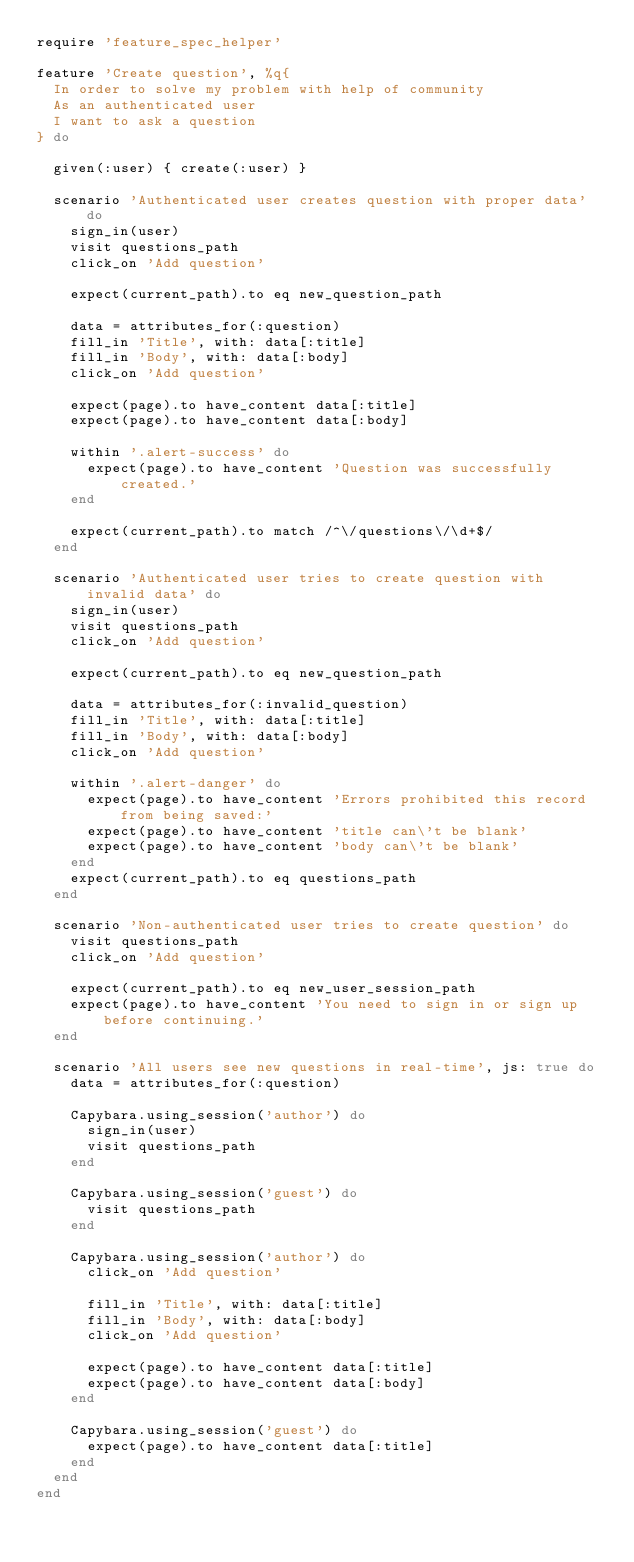<code> <loc_0><loc_0><loc_500><loc_500><_Ruby_>require 'feature_spec_helper'

feature 'Create question', %q{
  In order to solve my problem with help of community
  As an authenticated user
  I want to ask a question
} do

  given(:user) { create(:user) }

  scenario 'Authenticated user creates question with proper data' do
    sign_in(user)
    visit questions_path
    click_on 'Add question'

    expect(current_path).to eq new_question_path

    data = attributes_for(:question)
    fill_in 'Title', with: data[:title]
    fill_in 'Body', with: data[:body]
    click_on 'Add question'

    expect(page).to have_content data[:title]
    expect(page).to have_content data[:body]

    within '.alert-success' do
      expect(page).to have_content 'Question was successfully created.'
    end

    expect(current_path).to match /^\/questions\/\d+$/
  end

  scenario 'Authenticated user tries to create question with invalid data' do
    sign_in(user)
    visit questions_path
    click_on 'Add question'

    expect(current_path).to eq new_question_path

    data = attributes_for(:invalid_question)
    fill_in 'Title', with: data[:title]
    fill_in 'Body', with: data[:body]
    click_on 'Add question'

    within '.alert-danger' do
      expect(page).to have_content 'Errors prohibited this record from being saved:'
      expect(page).to have_content 'title can\'t be blank'
      expect(page).to have_content 'body can\'t be blank'
    end
    expect(current_path).to eq questions_path
  end

  scenario 'Non-authenticated user tries to create question' do
    visit questions_path
    click_on 'Add question'

    expect(current_path).to eq new_user_session_path
    expect(page).to have_content 'You need to sign in or sign up before continuing.'
  end

  scenario 'All users see new questions in real-time', js: true do
    data = attributes_for(:question)

    Capybara.using_session('author') do
      sign_in(user)
      visit questions_path
    end

    Capybara.using_session('guest') do
      visit questions_path
    end

    Capybara.using_session('author') do
      click_on 'Add question'

      fill_in 'Title', with: data[:title]
      fill_in 'Body', with: data[:body]
      click_on 'Add question'

      expect(page).to have_content data[:title]
      expect(page).to have_content data[:body]
    end

    Capybara.using_session('guest') do
      expect(page).to have_content data[:title]
    end
  end
end</code> 